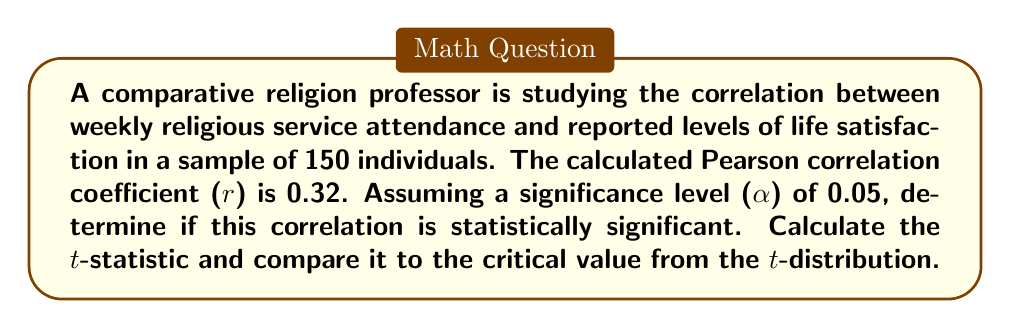Solve this math problem. To determine if the correlation is statistically significant, we'll follow these steps:

1. Calculate the t-statistic using the formula:
   $$t = \frac{r\sqrt{n-2}}{\sqrt{1-r^2}}$$
   where r is the correlation coefficient and n is the sample size.

2. Determine the degrees of freedom (df):
   $$df = n - 2 = 150 - 2 = 148$$

3. Find the critical value from the t-distribution table for a two-tailed test with α = 0.05 and df = 148.

4. Compare the calculated t-statistic to the critical value.

Step 1: Calculate the t-statistic
$$t = \frac{0.32\sqrt{150-2}}{\sqrt{1-0.32^2}}$$
$$t = \frac{0.32\sqrt{148}}{\sqrt{1-0.1024}}$$
$$t = \frac{0.32 * 12.1655}{0.9487}$$
$$t = 4.1079$$

Step 2: Degrees of freedom (df) = 148

Step 3: The critical value for a two-tailed test with α = 0.05 and df = 148 is approximately ±1.976.

Step 4: Compare the calculated t-statistic (4.1079) to the critical value (±1.976).

Since |4.1079| > 1.976, we reject the null hypothesis of no correlation.
Answer: The correlation is statistically significant (t = 4.1079, p < 0.05). 